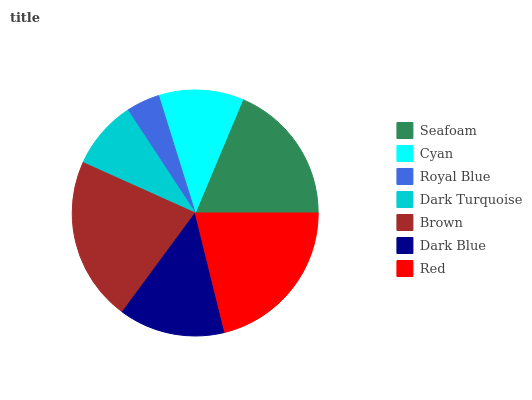Is Royal Blue the minimum?
Answer yes or no. Yes. Is Brown the maximum?
Answer yes or no. Yes. Is Cyan the minimum?
Answer yes or no. No. Is Cyan the maximum?
Answer yes or no. No. Is Seafoam greater than Cyan?
Answer yes or no. Yes. Is Cyan less than Seafoam?
Answer yes or no. Yes. Is Cyan greater than Seafoam?
Answer yes or no. No. Is Seafoam less than Cyan?
Answer yes or no. No. Is Dark Blue the high median?
Answer yes or no. Yes. Is Dark Blue the low median?
Answer yes or no. Yes. Is Cyan the high median?
Answer yes or no. No. Is Brown the low median?
Answer yes or no. No. 